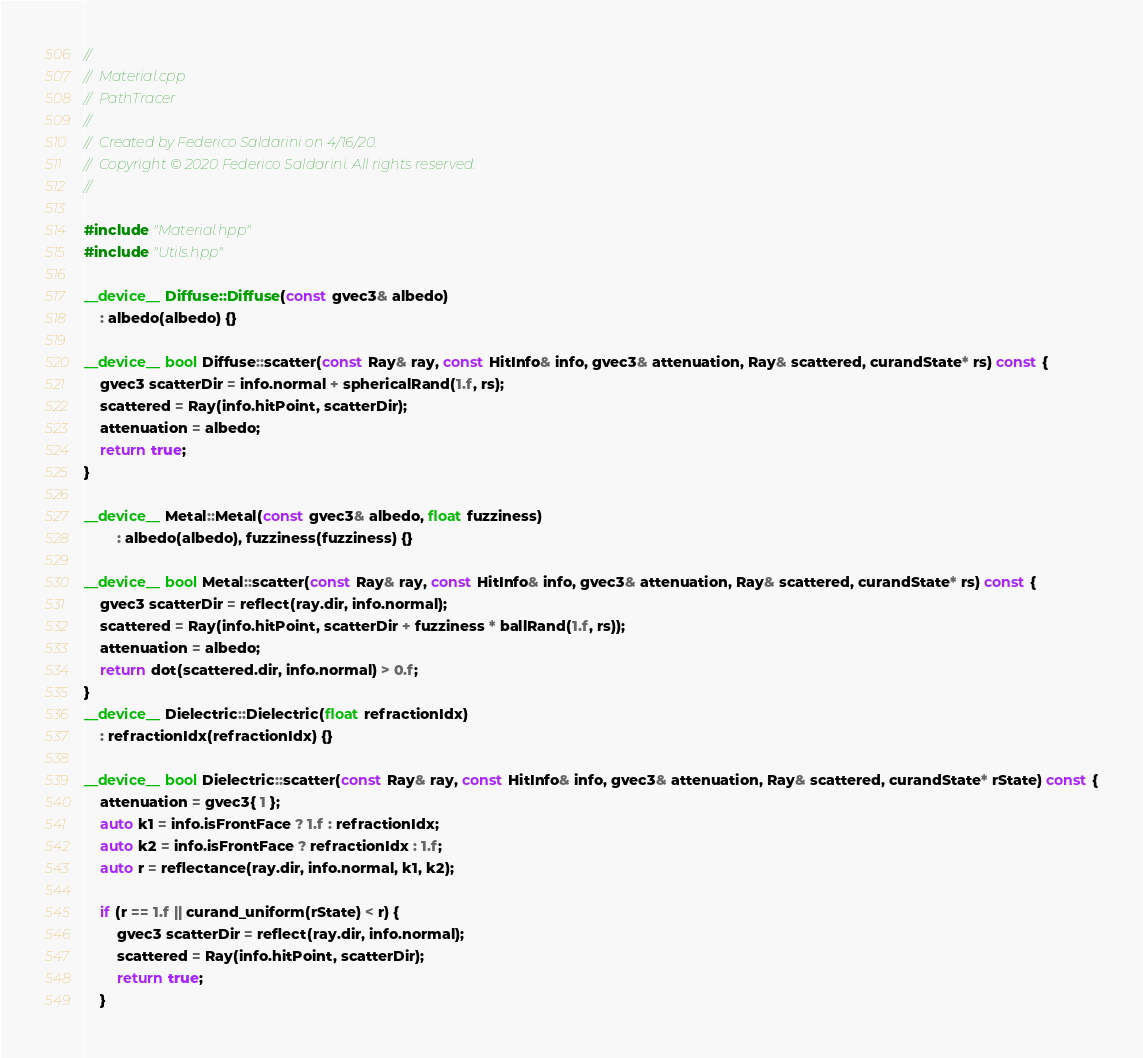Convert code to text. <code><loc_0><loc_0><loc_500><loc_500><_Cuda_>//
//  Material.cpp
//  PathTracer
//
//  Created by Federico Saldarini on 4/16/20.
//  Copyright © 2020 Federico Saldarini. All rights reserved.
//

#include "Material.hpp"
#include "Utils.hpp"

__device__ Diffuse::Diffuse(const gvec3& albedo)
	: albedo(albedo) {}

__device__ bool Diffuse::scatter(const Ray& ray, const HitInfo& info, gvec3& attenuation, Ray& scattered, curandState* rs) const {
	gvec3 scatterDir = info.normal + sphericalRand(1.f, rs);
	scattered = Ray(info.hitPoint, scatterDir);
	attenuation = albedo;
	return true;
}

__device__ Metal::Metal(const gvec3& albedo, float fuzziness)
		: albedo(albedo), fuzziness(fuzziness) {}

__device__ bool Metal::scatter(const Ray& ray, const HitInfo& info, gvec3& attenuation, Ray& scattered, curandState* rs) const {
	gvec3 scatterDir = reflect(ray.dir, info.normal);
	scattered = Ray(info.hitPoint, scatterDir + fuzziness * ballRand(1.f, rs));
	attenuation = albedo;
	return dot(scattered.dir, info.normal) > 0.f;
}
__device__ Dielectric::Dielectric(float refractionIdx)
	: refractionIdx(refractionIdx) {}

__device__ bool Dielectric::scatter(const Ray& ray, const HitInfo& info, gvec3& attenuation, Ray& scattered, curandState* rState) const {
	attenuation = gvec3{ 1 };
	auto k1 = info.isFrontFace ? 1.f : refractionIdx;
	auto k2 = info.isFrontFace ? refractionIdx : 1.f;
	auto r = reflectance(ray.dir, info.normal, k1, k2);

	if (r == 1.f || curand_uniform(rState) < r) {
		gvec3 scatterDir = reflect(ray.dir, info.normal);
		scattered = Ray(info.hitPoint, scatterDir);
		return true;
	}
</code> 